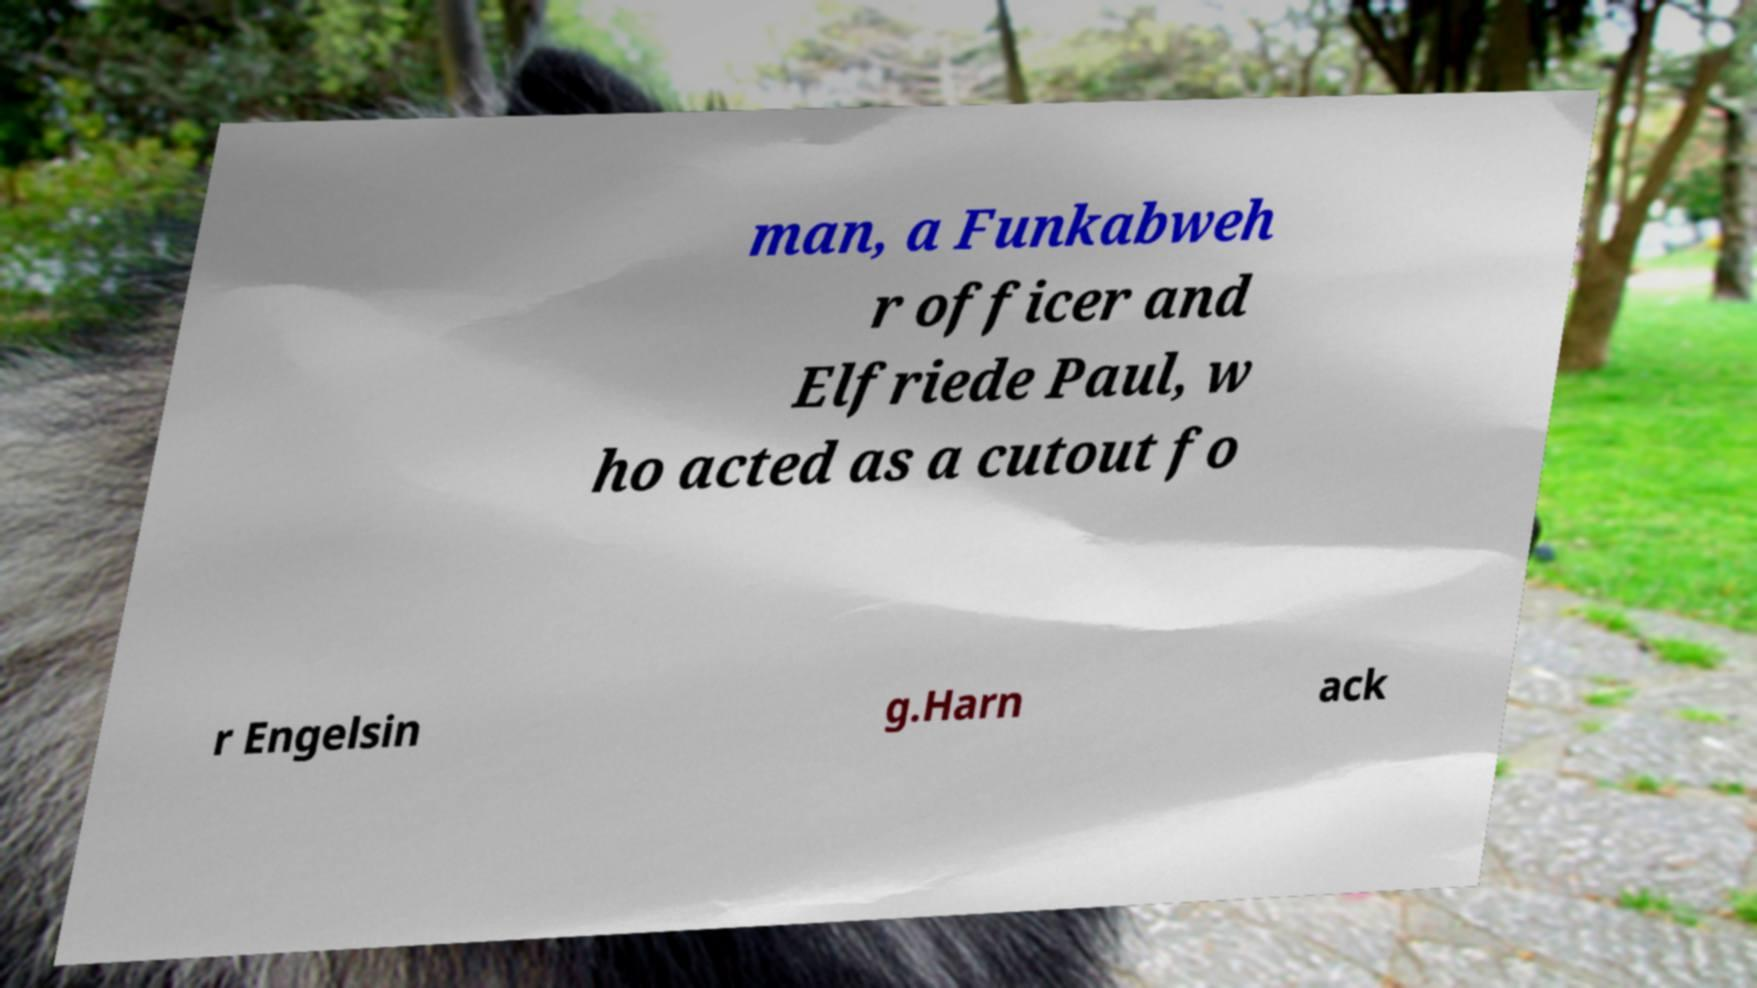Can you accurately transcribe the text from the provided image for me? man, a Funkabweh r officer and Elfriede Paul, w ho acted as a cutout fo r Engelsin g.Harn ack 